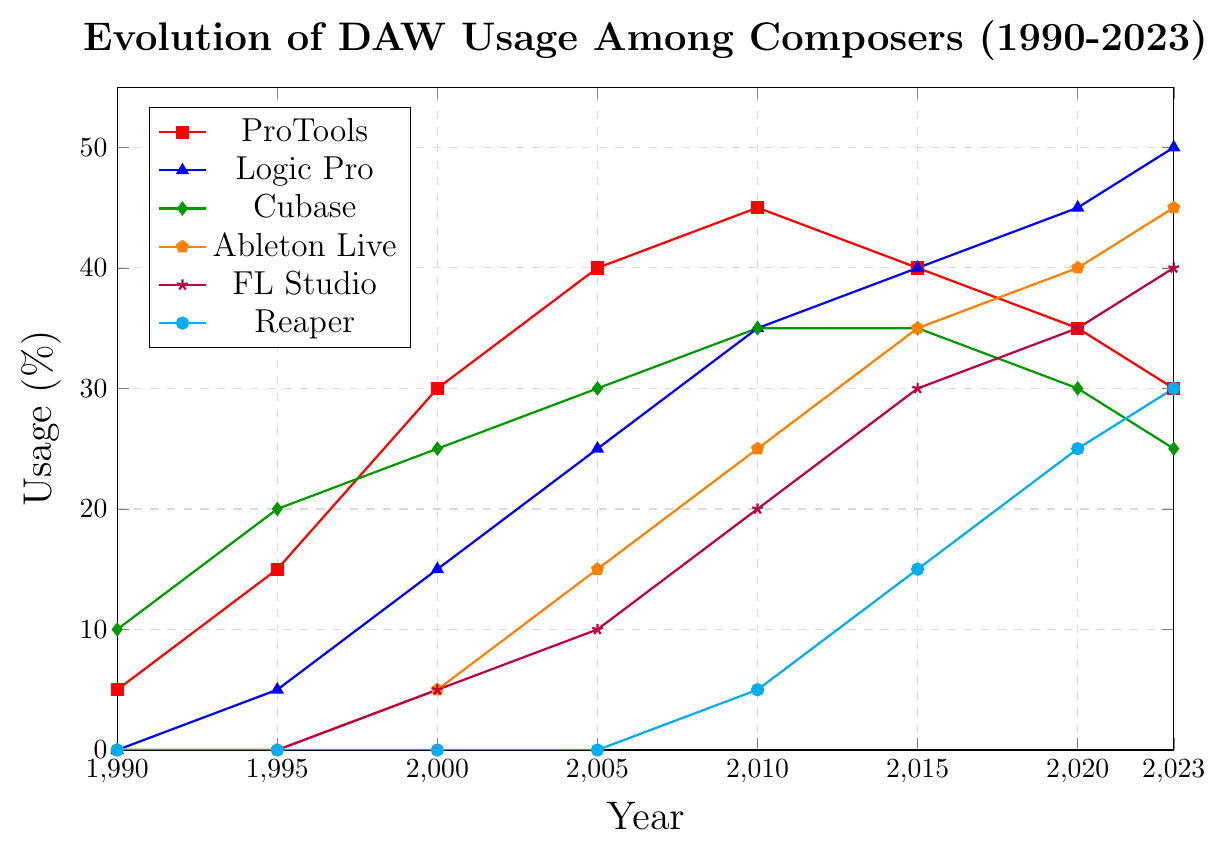When was the highest usage of Logic Pro, and what was the percentage? By examining the figure, you can pinpoint the year with the highest percentage for Logic Pro, which occurs around 2023. The corresponding percentage for that year is provided along the y-axis.
Answer: 2023, 50% Compare the usage of ProTools and Ableton Live in 2010. Which DAW had higher usage? In 2010, identify the points associated with ProTools and Ableton Live and compare their values on the y-axis. ProTools shows 45%, while Ableton Live shows 25%.
Answer: ProTools Between 1990 and 2023, which DAWs show a constant increase in usage? Look across the entire timeline for each DAW. Logic Pro, Ableton Live, FL Studio, and Reaper exhibit a consistent upward trend without periods of decline.
Answer: Logic Pro, Ableton Live, FL Studio, Reaper What is the difference in usage percentage between FL Studio and Cubase in 2023? Determine the values on the y-axis for FL Studio and Cubase in 2023. FL Studio is at 40% and Cubase at 25%. Subtract Cubase's percentage from FL Studio's.
Answer: 15% Which DAW had the largest increase in usage between any two consecutive time points, and what was the increase? Compare the differences in usage percentages between consecutive years for all DAWs. Between 2005 and 2010, Logic Pro increased from 25% to 35%, yielding the highest change of 10%.
Answer: Logic Pro, 10% Calculate the average usage of Cubase over the period from 1990 to 2023. Sum the usage percentages of Cubase over the years: 10 (1990) + 20 (1995) + 25 (2000) + 30 (2005) + 35 (2010) + 35 (2015) + 30 (2020) + 25 (2023). There are eight data points. Divide the total sum by 8. The calculation gives an average of 25%.
Answer: 25% Which DAW had no usage in 1990 but showed a marked increase by 2023? Compare the DAWs that start with 0% in 1990. Ableton Live, FL Studio, and Reaper were at 0% in 1990 but increased significantly by 2023.
Answer: Ableton Live, FL Studio, Reaper From 1990 to 2023, which DAW experienced a peak followed by a decline? Look for DAWs with a distinct peak and then a reduction in usage. ProTools peaked at ~45% around 2010 and then declined to 30% by 2023.
Answer: ProTools 